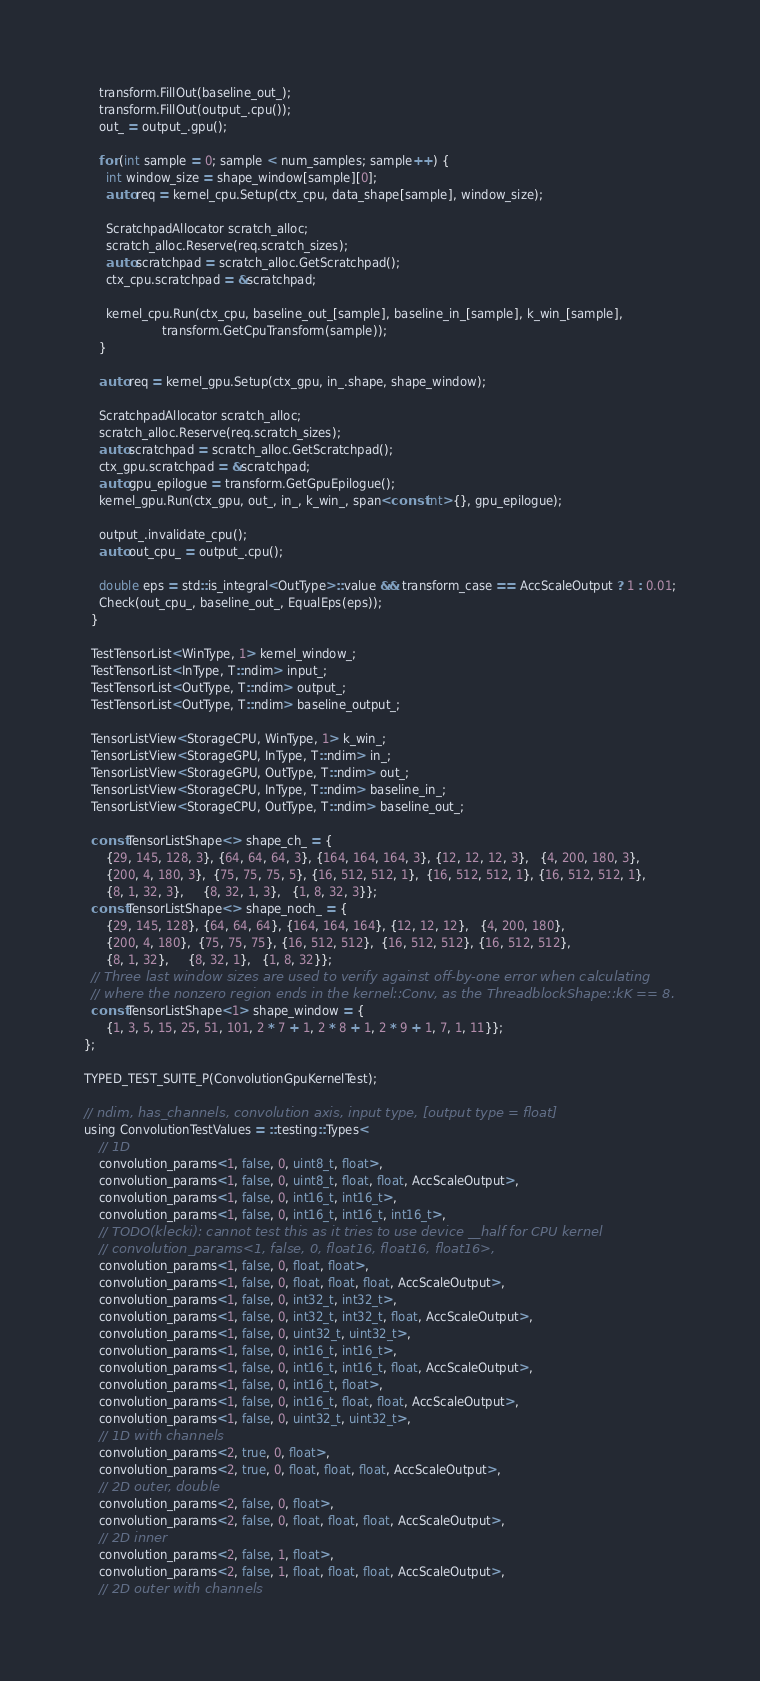<code> <loc_0><loc_0><loc_500><loc_500><_Cuda_>    transform.FillOut(baseline_out_);
    transform.FillOut(output_.cpu());
    out_ = output_.gpu();

    for (int sample = 0; sample < num_samples; sample++) {
      int window_size = shape_window[sample][0];
      auto req = kernel_cpu.Setup(ctx_cpu, data_shape[sample], window_size);

      ScratchpadAllocator scratch_alloc;
      scratch_alloc.Reserve(req.scratch_sizes);
      auto scratchpad = scratch_alloc.GetScratchpad();
      ctx_cpu.scratchpad = &scratchpad;

      kernel_cpu.Run(ctx_cpu, baseline_out_[sample], baseline_in_[sample], k_win_[sample],
                     transform.GetCpuTransform(sample));
    }

    auto req = kernel_gpu.Setup(ctx_gpu, in_.shape, shape_window);

    ScratchpadAllocator scratch_alloc;
    scratch_alloc.Reserve(req.scratch_sizes);
    auto scratchpad = scratch_alloc.GetScratchpad();
    ctx_gpu.scratchpad = &scratchpad;
    auto gpu_epilogue = transform.GetGpuEpilogue();
    kernel_gpu.Run(ctx_gpu, out_, in_, k_win_, span<const int>{}, gpu_epilogue);

    output_.invalidate_cpu();
    auto out_cpu_ = output_.cpu();

    double eps = std::is_integral<OutType>::value && transform_case == AccScaleOutput ? 1 : 0.01;
    Check(out_cpu_, baseline_out_, EqualEps(eps));
  }

  TestTensorList<WinType, 1> kernel_window_;
  TestTensorList<InType, T::ndim> input_;
  TestTensorList<OutType, T::ndim> output_;
  TestTensorList<OutType, T::ndim> baseline_output_;

  TensorListView<StorageCPU, WinType, 1> k_win_;
  TensorListView<StorageGPU, InType, T::ndim> in_;
  TensorListView<StorageGPU, OutType, T::ndim> out_;
  TensorListView<StorageCPU, InType, T::ndim> baseline_in_;
  TensorListView<StorageCPU, OutType, T::ndim> baseline_out_;

  const TensorListShape<> shape_ch_ = {
      {29, 145, 128, 3}, {64, 64, 64, 3}, {164, 164, 164, 3}, {12, 12, 12, 3},   {4, 200, 180, 3},
      {200, 4, 180, 3},  {75, 75, 75, 5}, {16, 512, 512, 1},  {16, 512, 512, 1}, {16, 512, 512, 1},
      {8, 1, 32, 3},     {8, 32, 1, 3},   {1, 8, 32, 3}};
  const TensorListShape<> shape_noch_ = {
      {29, 145, 128}, {64, 64, 64}, {164, 164, 164}, {12, 12, 12},   {4, 200, 180},
      {200, 4, 180},  {75, 75, 75}, {16, 512, 512},  {16, 512, 512}, {16, 512, 512},
      {8, 1, 32},     {8, 32, 1},   {1, 8, 32}};
  // Three last window sizes are used to verify against off-by-one error when calculating
  // where the nonzero region ends in the kernel::Conv, as the ThreadblockShape::kK == 8.
  const TensorListShape<1> shape_window = {
      {1, 3, 5, 15, 25, 51, 101, 2 * 7 + 1, 2 * 8 + 1, 2 * 9 + 1, 7, 1, 11}};
};

TYPED_TEST_SUITE_P(ConvolutionGpuKernelTest);

// ndim, has_channels, convolution axis, input type, [output type = float]
using ConvolutionTestValues = ::testing::Types<
    // 1D
    convolution_params<1, false, 0, uint8_t, float>,
    convolution_params<1, false, 0, uint8_t, float, float, AccScaleOutput>,
    convolution_params<1, false, 0, int16_t, int16_t>,
    convolution_params<1, false, 0, int16_t, int16_t, int16_t>,
    // TODO(klecki): cannot test this as it tries to use device __half for CPU kernel
    // convolution_params<1, false, 0, float16, float16, float16>,
    convolution_params<1, false, 0, float, float>,
    convolution_params<1, false, 0, float, float, float, AccScaleOutput>,
    convolution_params<1, false, 0, int32_t, int32_t>,
    convolution_params<1, false, 0, int32_t, int32_t, float, AccScaleOutput>,
    convolution_params<1, false, 0, uint32_t, uint32_t>,
    convolution_params<1, false, 0, int16_t, int16_t>,
    convolution_params<1, false, 0, int16_t, int16_t, float, AccScaleOutput>,
    convolution_params<1, false, 0, int16_t, float>,
    convolution_params<1, false, 0, int16_t, float, float, AccScaleOutput>,
    convolution_params<1, false, 0, uint32_t, uint32_t>,
    // 1D with channels
    convolution_params<2, true, 0, float>,
    convolution_params<2, true, 0, float, float, float, AccScaleOutput>,
    // 2D outer, double
    convolution_params<2, false, 0, float>,
    convolution_params<2, false, 0, float, float, float, AccScaleOutput>,
    // 2D inner
    convolution_params<2, false, 1, float>,
    convolution_params<2, false, 1, float, float, float, AccScaleOutput>,
    // 2D outer with channels</code> 